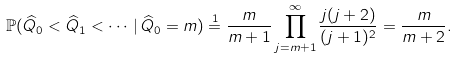<formula> <loc_0><loc_0><loc_500><loc_500>\mathbb { P } ( \widehat { Q } _ { 0 } < \widehat { Q } _ { 1 } < \cdots \, | \, \widehat { Q } _ { 0 } = m ) \stackrel { 1 } { = } \frac { m } { m + 1 } \prod _ { j = { m + 1 } } ^ { \infty } \frac { j ( j + 2 ) } { ( j + 1 ) ^ { 2 } } = \frac { m } { m + 2 } .</formula> 